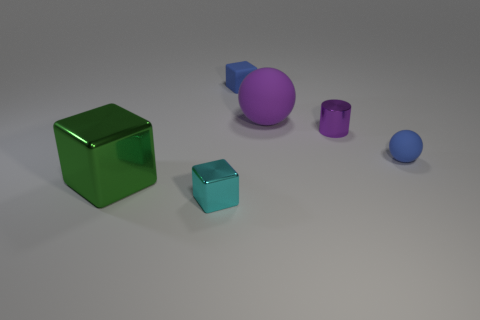How many matte things are either small yellow objects or big green blocks?
Provide a succinct answer. 0. What is the shape of the tiny metallic thing that is the same color as the big matte object?
Make the answer very short. Cylinder. How many brown things are the same size as the blue matte block?
Your answer should be compact. 0. There is a metal object that is both to the right of the big metal block and in front of the small blue sphere; what is its color?
Provide a succinct answer. Cyan. How many things are either big blue shiny spheres or small rubber spheres?
Offer a very short reply. 1. How many large things are either metal blocks or matte things?
Your answer should be compact. 2. Is there any other thing that is the same color as the large rubber object?
Ensure brevity in your answer.  Yes. There is a thing that is on the right side of the large sphere and left of the blue ball; what is its size?
Keep it short and to the point. Small. Is the color of the tiny block behind the green metal cube the same as the small matte thing on the right side of the small purple metal cylinder?
Provide a short and direct response. Yes. How many other objects are there of the same material as the large purple thing?
Your response must be concise. 2. 